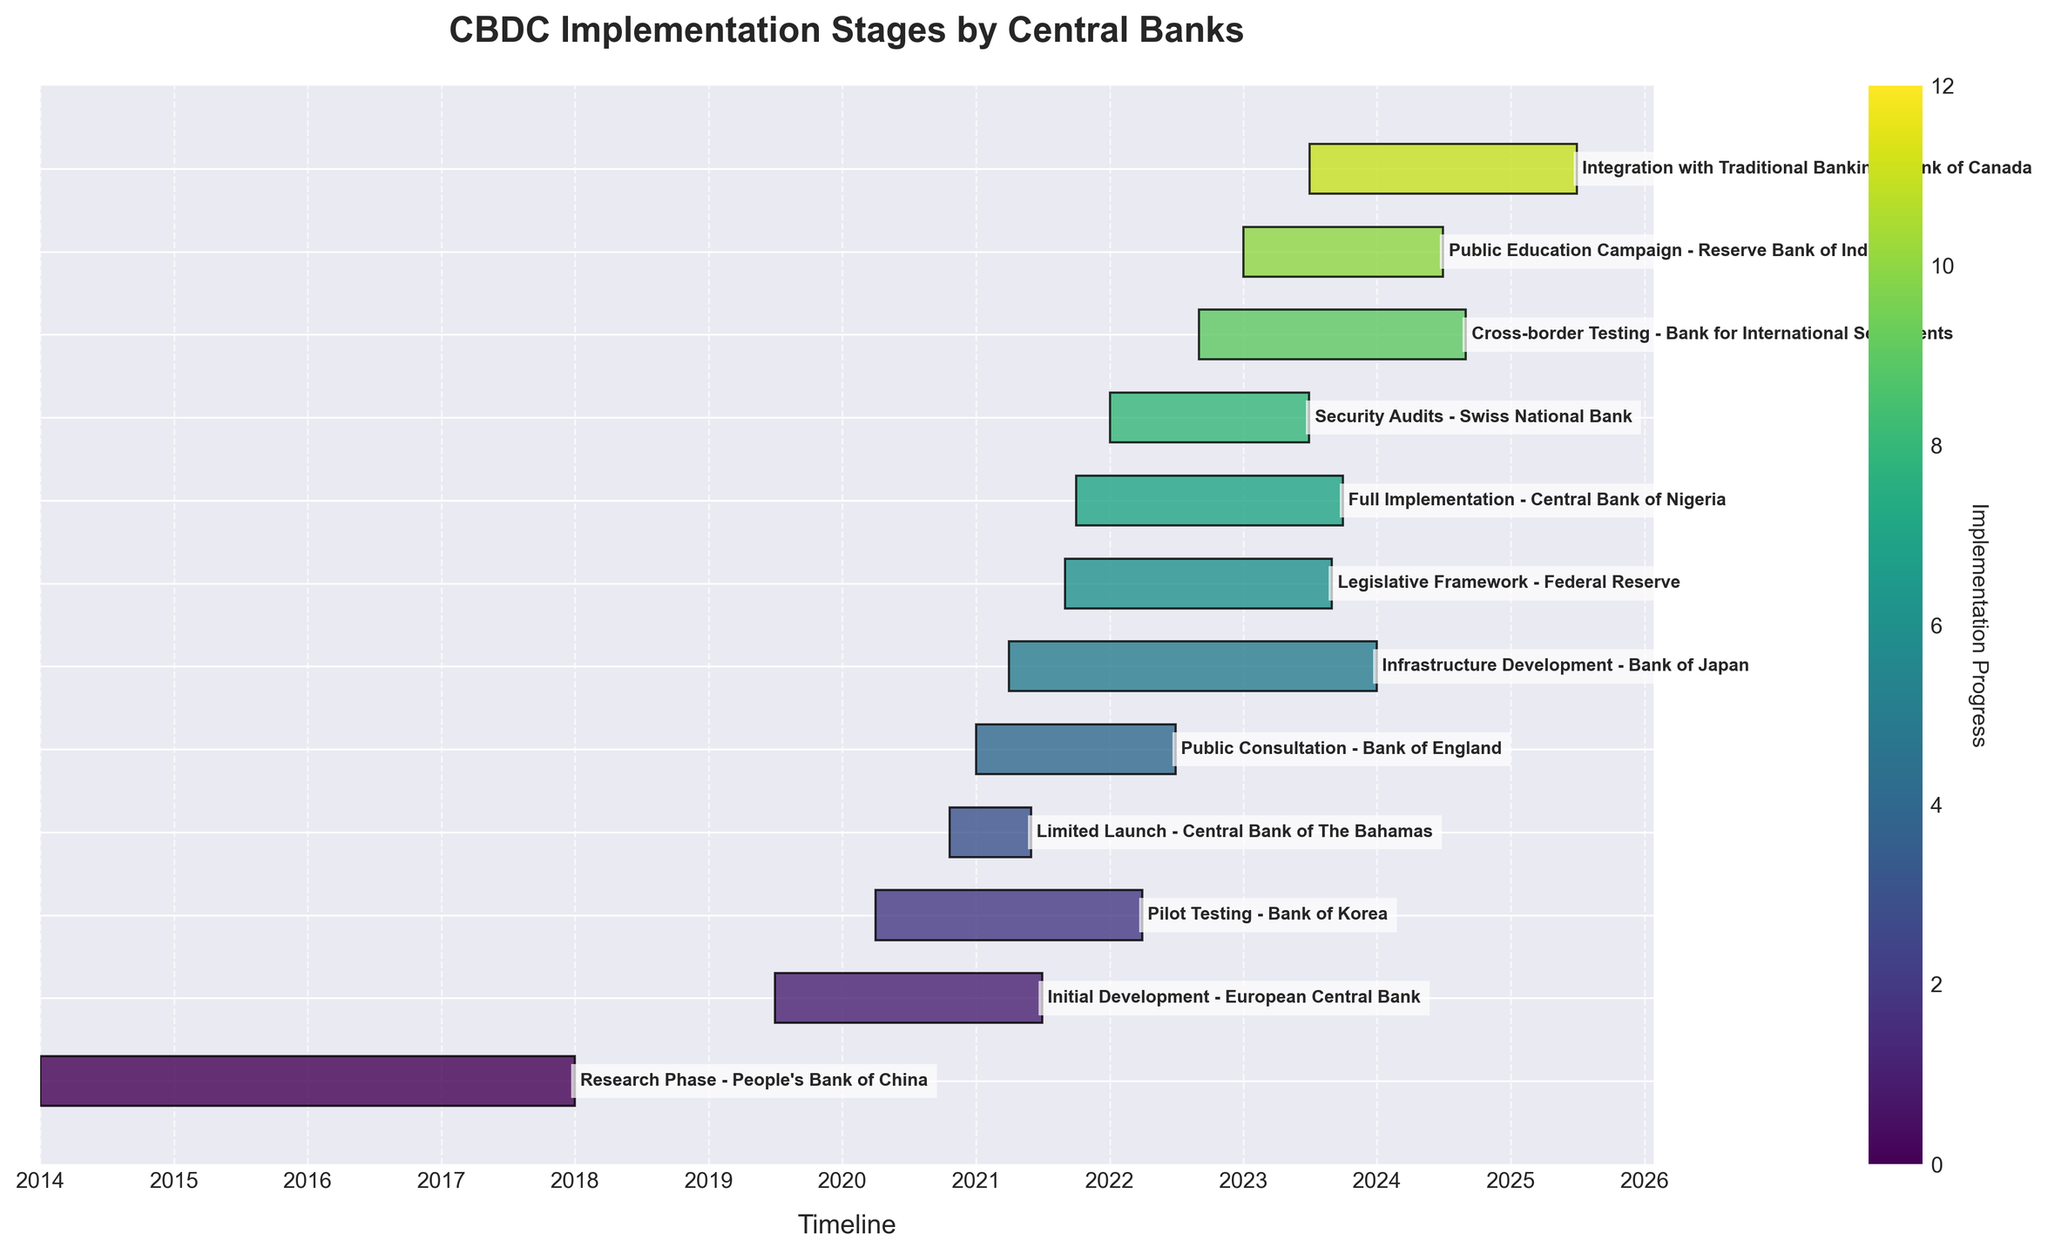What is the title of the chart? The title of the chart is displayed at the top of the figure in bold font. It reads "CBDC Implementation Stages by Central Banks".
Answer: CBDC Implementation Stages by Central Banks Which central bank started its CBDC implementation process last? By looking at the x-axis that shows the timeline and identifying the task that starts latest, "Integration with Traditional Banking - Bank of Canada" starts in July 2023, which is the latest.
Answer: Bank of Canada Which task has the longest duration? To determine the longest duration, we compare the width of the bars. "Integration with Traditional Banking - Bank of Canada" spans from July 2023 to June 2025, which is approximately two years.
Answer: Integration with Traditional Banking - Bank of Canada How long did the "Research Phase" by People's Bank of China last? The "Research Phase - People's Bank of China" spans from January 2014 to December 2017. Calculating the duration: from January 2014 to December 2017 is 4 years.
Answer: 4 years Which central bank's task overlaps with the "Legislative Framework - Federal Reserve"? To find overlapping tasks, look for bars that extend into the timeline of the "Legislative Framework - Federal Reserve" from September 2021 to August 2023. "Infrastructure Development - Bank of Japan," "Full Implementation - Central Bank of Nigeria," "Cross-border Testing - Bank for International Settlements," and "Security Audits - Swiss National Bank" overlap.
Answer: Bank of Japan, Central Bank of Nigeria, Bank for International Settlements, Swiss National Bank Which task finished first? By examining the timeline and looking for the shortest bar on the left side, "Research Phase - People's Bank of China" completed in December 2017.
Answer: Research Phase - People's Bank of China How many tasks were either ongoing or had started by 2021? To determine this, identify all tasks that either started or were ongoing in 2021. These include: "Initial Development - European Central Bank," "Pilot Testing - Bank of Korea," "Limited Launch - Central Bank of The Bahamas," "Public Consultation - Bank of England," "Legislative Framework - Federal Reserve," "Infrastructure Development - Bank of Japan," "Full Implementation - Central Bank of Nigeria." This counts up to seven tasks.
Answer: 7 tasks When did "Security Audits" by the Swiss National Bank take place, and how long did it last? "Security Audits - Swiss National Bank" started in January 2022 and ended in June 2023. The duration from January 2022 to June 2023 is about 1.5 years.
Answer: January 2022 to June 2023, 1.5 years Which tasks were active in April 2022? Identify bars that span over April 2022. The tasks include "Pilot Testing - Bank of Korea," "Public Consultation - Bank of England," "Legislative Framework - Federal Reserve," "Infrastructure Development - Bank of Japan," "Full Implementation - Central Bank of Nigeria," and "Cross-border Testing - Bank for International Settlements."
Answer: Bank of Korea, Bank of England, Federal Reserve, Bank of Japan, Central Bank of Nigeria, Bank for International Settlements How many tasks are expected to finish after 2023? Tasks that extend beyond 2023 are: "Cross-border Testing - Bank for International Settlements," "Public Education Campaign - Reserve Bank of India," "Integration with Traditional Banking - Bank of Canada". There are three tasks in total.
Answer: 3 tasks 